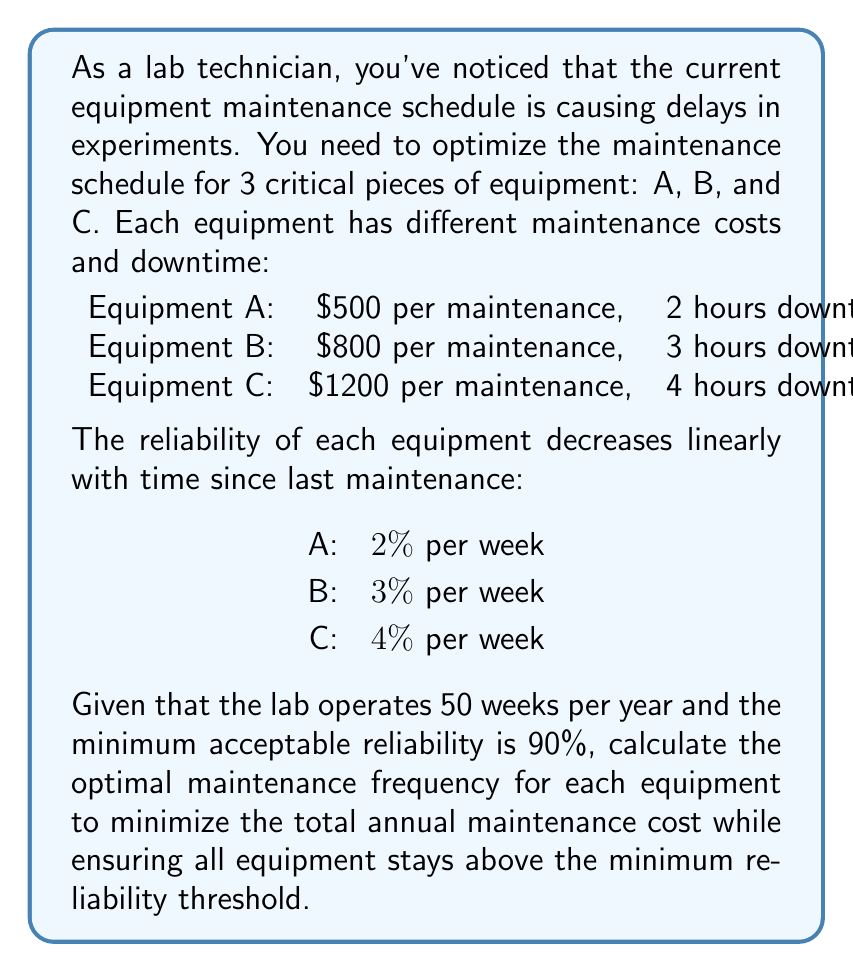Provide a solution to this math problem. To solve this optimization problem, we'll follow these steps:

1. Calculate the maximum time between maintenance for each equipment:
   For equipment A: $0.02x = 0.10$, where x is weeks
   $$x = \frac{0.10}{0.02} = 5 \text{ weeks}$$
   For equipment B: $0.03x = 0.10$
   $$x = \frac{0.10}{0.03} = 3.33 \text{ weeks}$$
   For equipment C: $0.04x = 0.10$
   $$x = \frac{0.10}{0.04} = 2.5 \text{ weeks}$$

2. Calculate the number of maintenances per year for each equipment:
   Equipment A: $\frac{50 \text{ weeks}}{5 \text{ weeks}} = 10$ maintenances/year
   Equipment B: $\frac{50 \text{ weeks}}{3.33 \text{ weeks}} = 15$ maintenances/year
   Equipment C: $\frac{50 \text{ weeks}}{2.5 \text{ weeks}} = 20$ maintenances/year

3. Calculate the annual maintenance cost for each equipment:
   Equipment A: $10 \times $500 = $5,000
   Equipment B: $15 \times $800 = $12,000
   Equipment C: $20 \times $1200 = $24,000

4. Calculate the total annual maintenance cost:
   $$\text{Total cost} = $5,000 + $12,000 + $24,000 = $41,000$$

5. Calculate the total annual downtime:
   Equipment A: $10 \times 2 \text{ hours} = 20 \text{ hours}$
   Equipment B: $15 \times 3 \text{ hours} = 45 \text{ hours}$
   Equipment C: $20 \times 4 \text{ hours} = 80 \text{ hours}$
   $$\text{Total downtime} = 20 + 45 + 80 = 145 \text{ hours}$$

This schedule ensures that all equipment stays above the 90% reliability threshold while minimizing the total annual maintenance cost.
Answer: The optimal maintenance schedule is:
Equipment A: Every 5 weeks (10 times/year)
Equipment B: Every 3.33 weeks (15 times/year)
Equipment C: Every 2.5 weeks (20 times/year)

Total annual maintenance cost: $41,000
Total annual downtime: 145 hours 